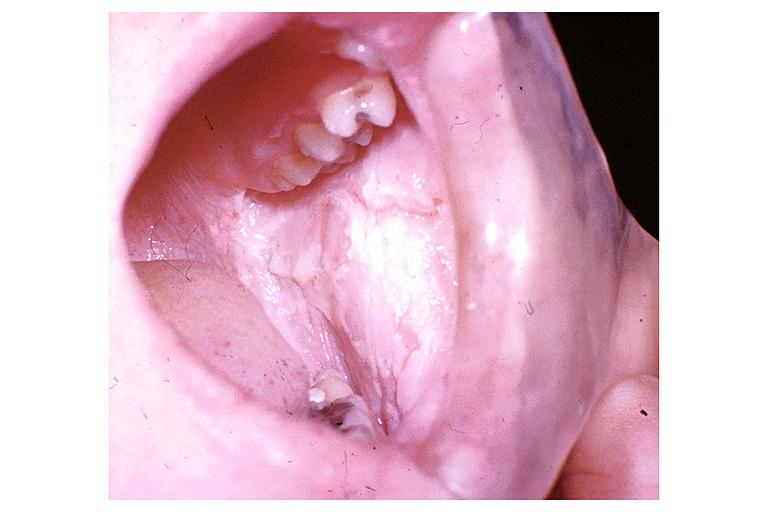what is present?
Answer the question using a single word or phrase. Oral 